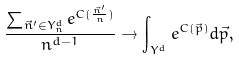Convert formula to latex. <formula><loc_0><loc_0><loc_500><loc_500>\frac { \sum _ { \vec { n } ^ { \prime } \in Y ^ { d } _ { n } } e ^ { C ( \frac { \vec { n } ^ { \prime } } { n } ) } } { n ^ { d - 1 } } \to \int _ { Y ^ { d } } e ^ { C ( \vec { p } ) } d \vec { p } ,</formula> 